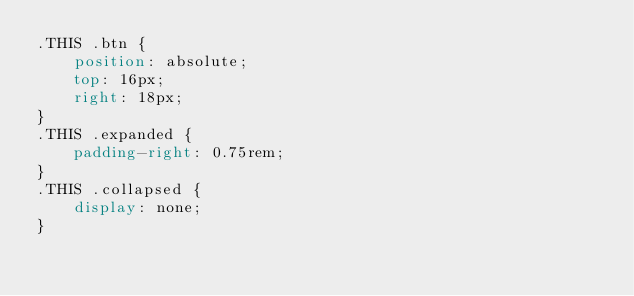Convert code to text. <code><loc_0><loc_0><loc_500><loc_500><_CSS_>.THIS .btn {
    position: absolute;
    top: 16px;
    right: 18px;
}
.THIS .expanded {
    padding-right: 0.75rem;
}
.THIS .collapsed {
    display: none;
}
</code> 